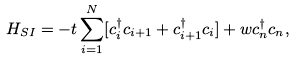<formula> <loc_0><loc_0><loc_500><loc_500>H _ { S I } = - t \sum _ { i = 1 } ^ { N } [ c _ { i } ^ { \dagger } c _ { i + 1 } + c _ { i + 1 } ^ { \dagger } c _ { i } ] + w c _ { n } ^ { \dagger } c _ { n } ,</formula> 